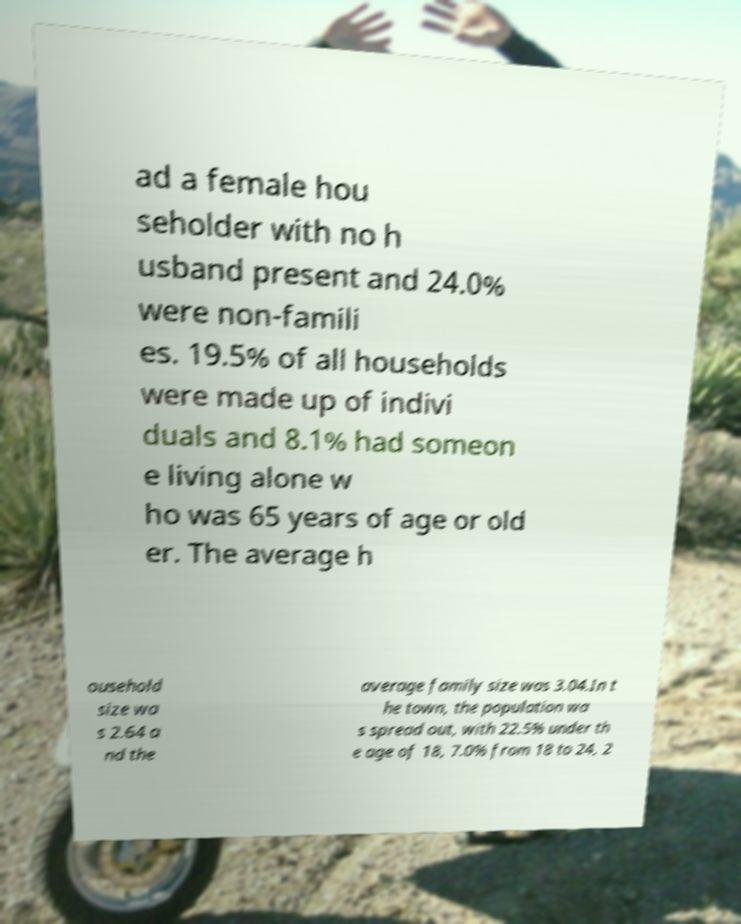For documentation purposes, I need the text within this image transcribed. Could you provide that? ad a female hou seholder with no h usband present and 24.0% were non-famili es. 19.5% of all households were made up of indivi duals and 8.1% had someon e living alone w ho was 65 years of age or old er. The average h ousehold size wa s 2.64 a nd the average family size was 3.04.In t he town, the population wa s spread out, with 22.5% under th e age of 18, 7.0% from 18 to 24, 2 